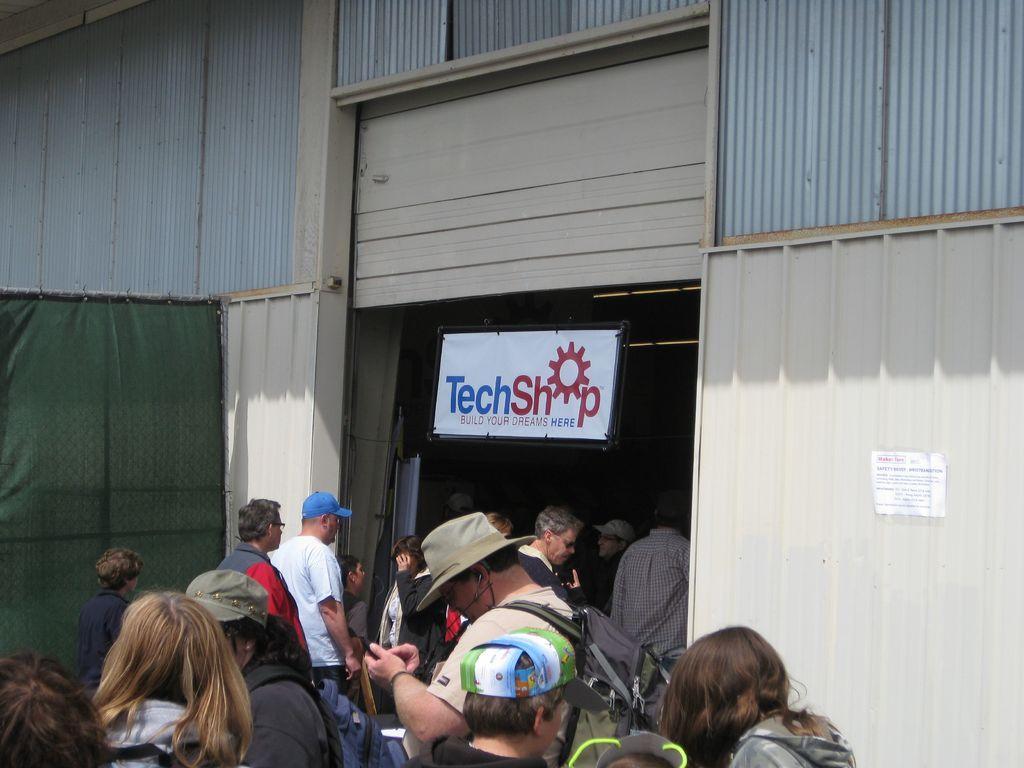Please provide a concise description of this image. In the foreground of the image we can see a group of people are standing. In the middle of the image we can see a board and some was text written on it. Some people are entering inside the shutter and a green color curtain is there. On the top of the image we can see steel tins. 